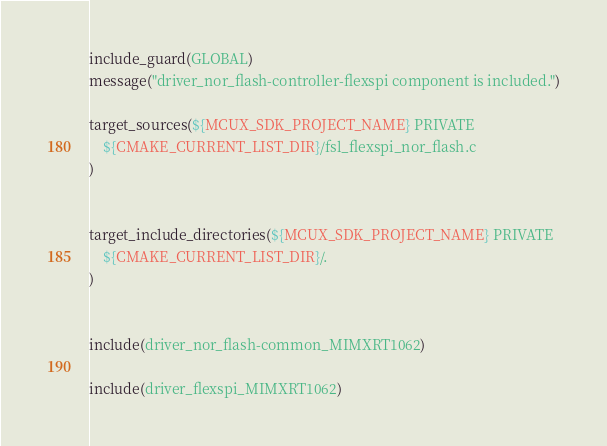<code> <loc_0><loc_0><loc_500><loc_500><_CMake_>include_guard(GLOBAL)
message("driver_nor_flash-controller-flexspi component is included.")

target_sources(${MCUX_SDK_PROJECT_NAME} PRIVATE
    ${CMAKE_CURRENT_LIST_DIR}/fsl_flexspi_nor_flash.c
)


target_include_directories(${MCUX_SDK_PROJECT_NAME} PRIVATE
    ${CMAKE_CURRENT_LIST_DIR}/.
)


include(driver_nor_flash-common_MIMXRT1062)

include(driver_flexspi_MIMXRT1062)

</code> 